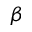Convert formula to latex. <formula><loc_0><loc_0><loc_500><loc_500>\beta</formula> 